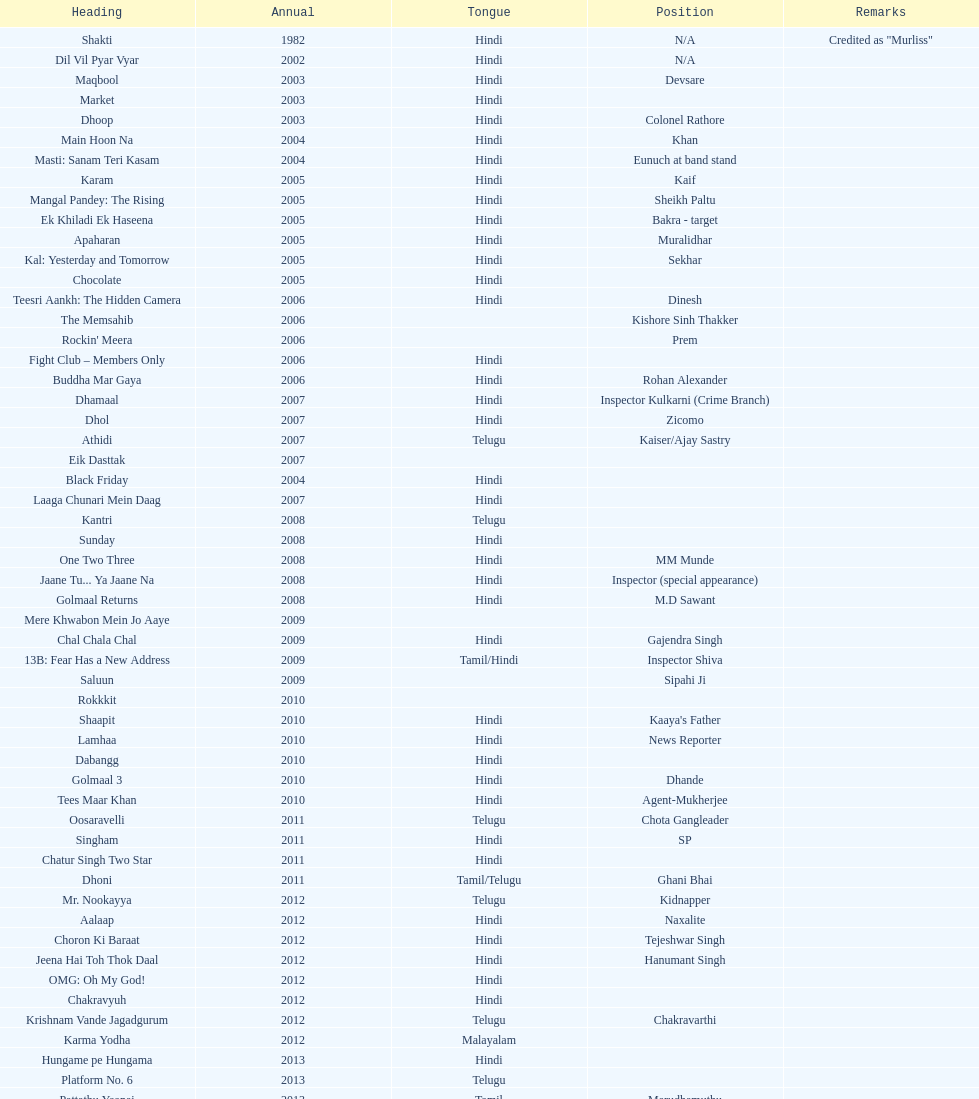What movie did this actor star in after they starred in dil vil pyar vyar in 2002? Maqbool. 